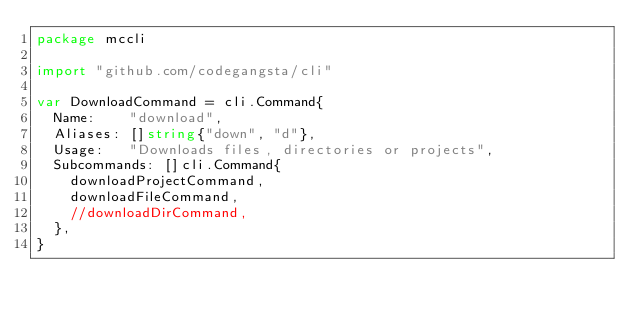Convert code to text. <code><loc_0><loc_0><loc_500><loc_500><_Go_>package mccli

import "github.com/codegangsta/cli"

var DownloadCommand = cli.Command{
	Name:    "download",
	Aliases: []string{"down", "d"},
	Usage:   "Downloads files, directories or projects",
	Subcommands: []cli.Command{
		downloadProjectCommand,
		downloadFileCommand,
		//downloadDirCommand,
	},
}
</code> 